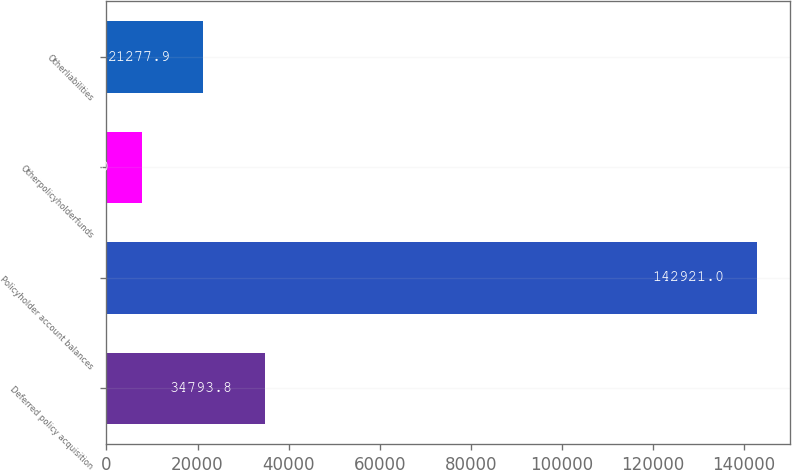Convert chart to OTSL. <chart><loc_0><loc_0><loc_500><loc_500><bar_chart><fcel>Deferred policy acquisition<fcel>Policyholder account balances<fcel>Otherpolicyholderfunds<fcel>Otherliabilities<nl><fcel>34793.8<fcel>142921<fcel>7762<fcel>21277.9<nl></chart> 